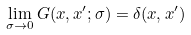Convert formula to latex. <formula><loc_0><loc_0><loc_500><loc_500>\lim _ { \sigma \rightarrow 0 } G ( x , x ^ { \prime } ; \sigma ) = \delta ( x , x ^ { \prime } )</formula> 